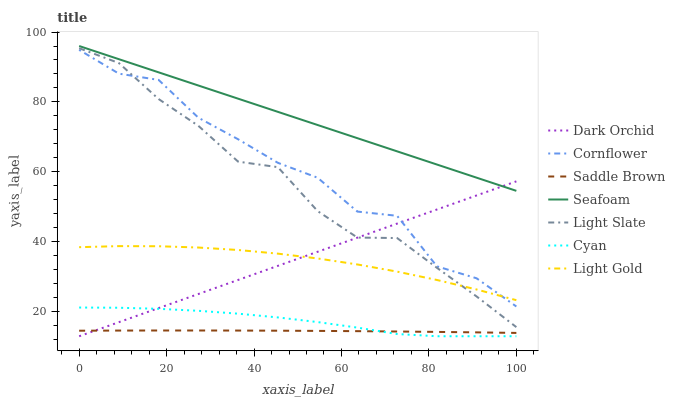Does Saddle Brown have the minimum area under the curve?
Answer yes or no. Yes. Does Seafoam have the maximum area under the curve?
Answer yes or no. Yes. Does Light Slate have the minimum area under the curve?
Answer yes or no. No. Does Light Slate have the maximum area under the curve?
Answer yes or no. No. Is Dark Orchid the smoothest?
Answer yes or no. Yes. Is Cornflower the roughest?
Answer yes or no. Yes. Is Light Slate the smoothest?
Answer yes or no. No. Is Light Slate the roughest?
Answer yes or no. No. Does Dark Orchid have the lowest value?
Answer yes or no. Yes. Does Light Slate have the lowest value?
Answer yes or no. No. Does Seafoam have the highest value?
Answer yes or no. Yes. Does Light Slate have the highest value?
Answer yes or no. No. Is Saddle Brown less than Light Gold?
Answer yes or no. Yes. Is Light Slate greater than Cyan?
Answer yes or no. Yes. Does Saddle Brown intersect Dark Orchid?
Answer yes or no. Yes. Is Saddle Brown less than Dark Orchid?
Answer yes or no. No. Is Saddle Brown greater than Dark Orchid?
Answer yes or no. No. Does Saddle Brown intersect Light Gold?
Answer yes or no. No. 